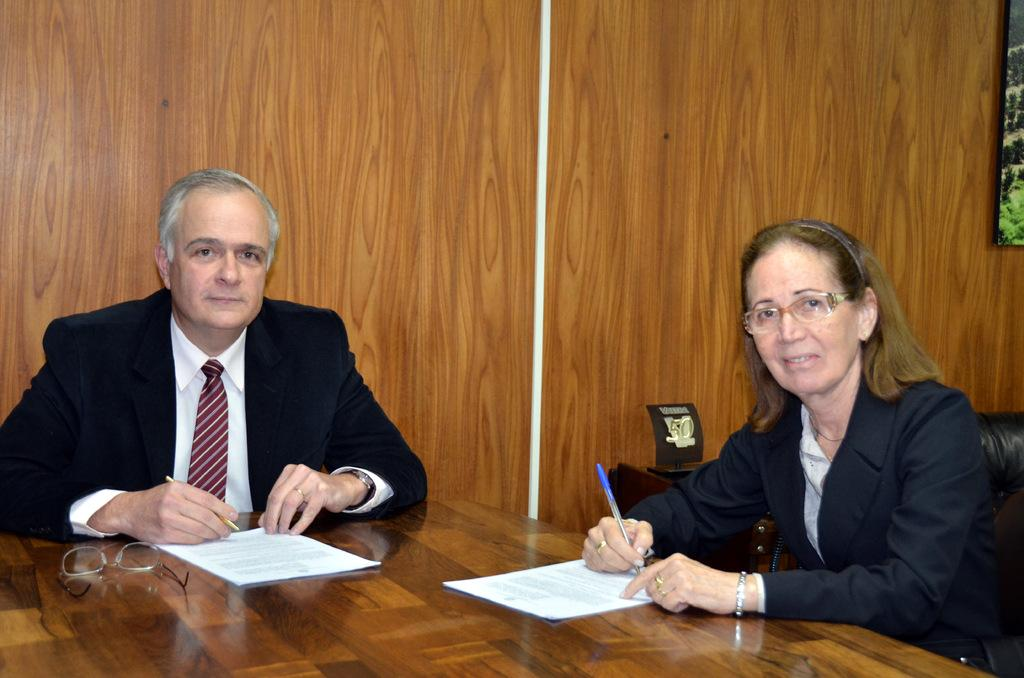How many people are in the image? There are two people in the image. Where is the first person sitting in the image? The first person is sitting on the left side. Where is the second person sitting in the image? The second person is sitting on the right side. Can you describe any small details in the image? There is a small mark or spec in the bottom left corner of the image. What type of bushes can be seen in the background of the image? There are no bushes visible in the image. Is the image painted on a canvas? The facts provided do not mention anything about the image being painted on a canvas, so we cannot determine that from the information given. 